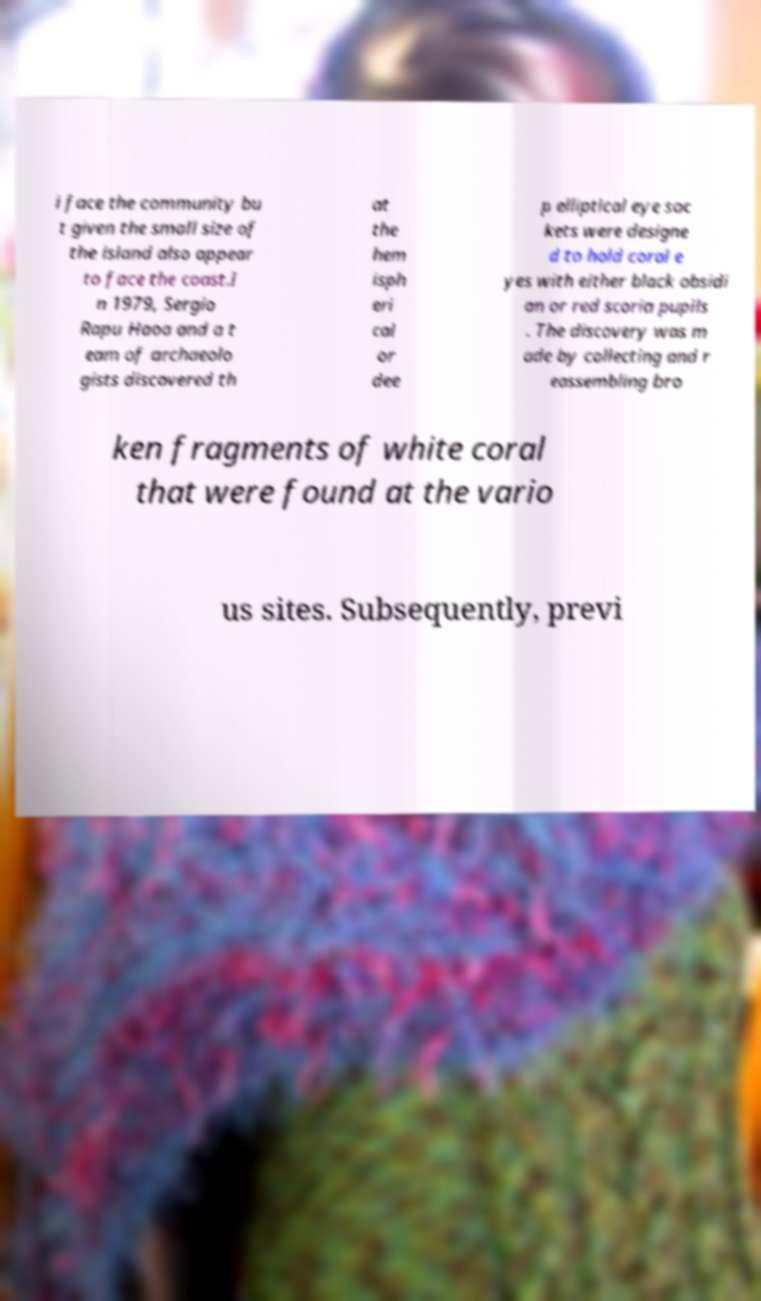For documentation purposes, I need the text within this image transcribed. Could you provide that? i face the community bu t given the small size of the island also appear to face the coast.I n 1979, Sergio Rapu Haoa and a t eam of archaeolo gists discovered th at the hem isph eri cal or dee p elliptical eye soc kets were designe d to hold coral e yes with either black obsidi an or red scoria pupils . The discovery was m ade by collecting and r eassembling bro ken fragments of white coral that were found at the vario us sites. Subsequently, previ 